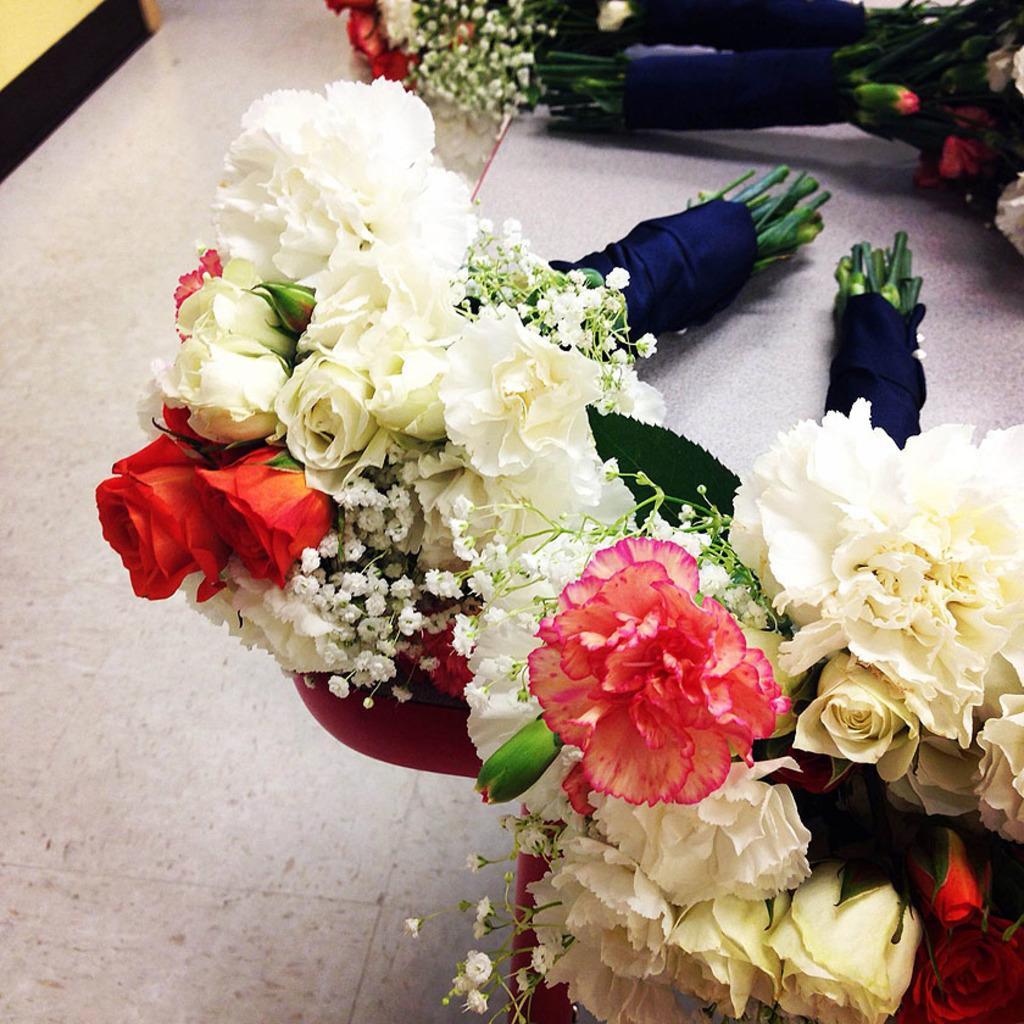Describe this image in one or two sentences. In this image we can see bunches of flowers on the table. 